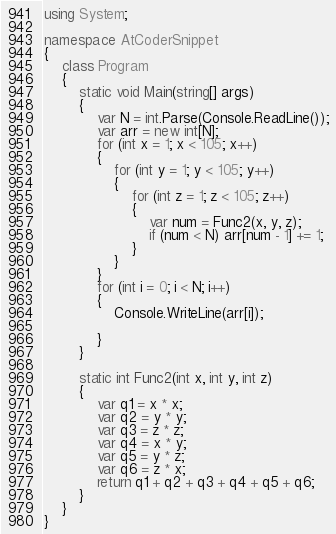Convert code to text. <code><loc_0><loc_0><loc_500><loc_500><_C#_>using System;
 
namespace AtCoderSnippet
{
    class Program
    {
        static void Main(string[] args)
        {
            var N = int.Parse(Console.ReadLine());
            var arr = new int[N];
            for (int x = 1; x < 105; x++)
            {
                for (int y = 1; y < 105; y++)
                {
                    for (int z = 1; z < 105; z++)
                    {
                        var num = Func2(x, y, z);
                        if (num < N) arr[num - 1] += 1;
                    }
                }
            }
            for (int i = 0; i < N; i++)
            {
                Console.WriteLine(arr[i]);

            }
        }

        static int Func2(int x, int y, int z)
        {
            var q1 = x * x;
            var q2 = y * y;
            var q3 = z * z;
            var q4 = x * y;
            var q5 = y * z;
            var q6 = z * x;
            return q1 + q2 + q3 + q4 + q5 + q6;
        }
    }
}</code> 